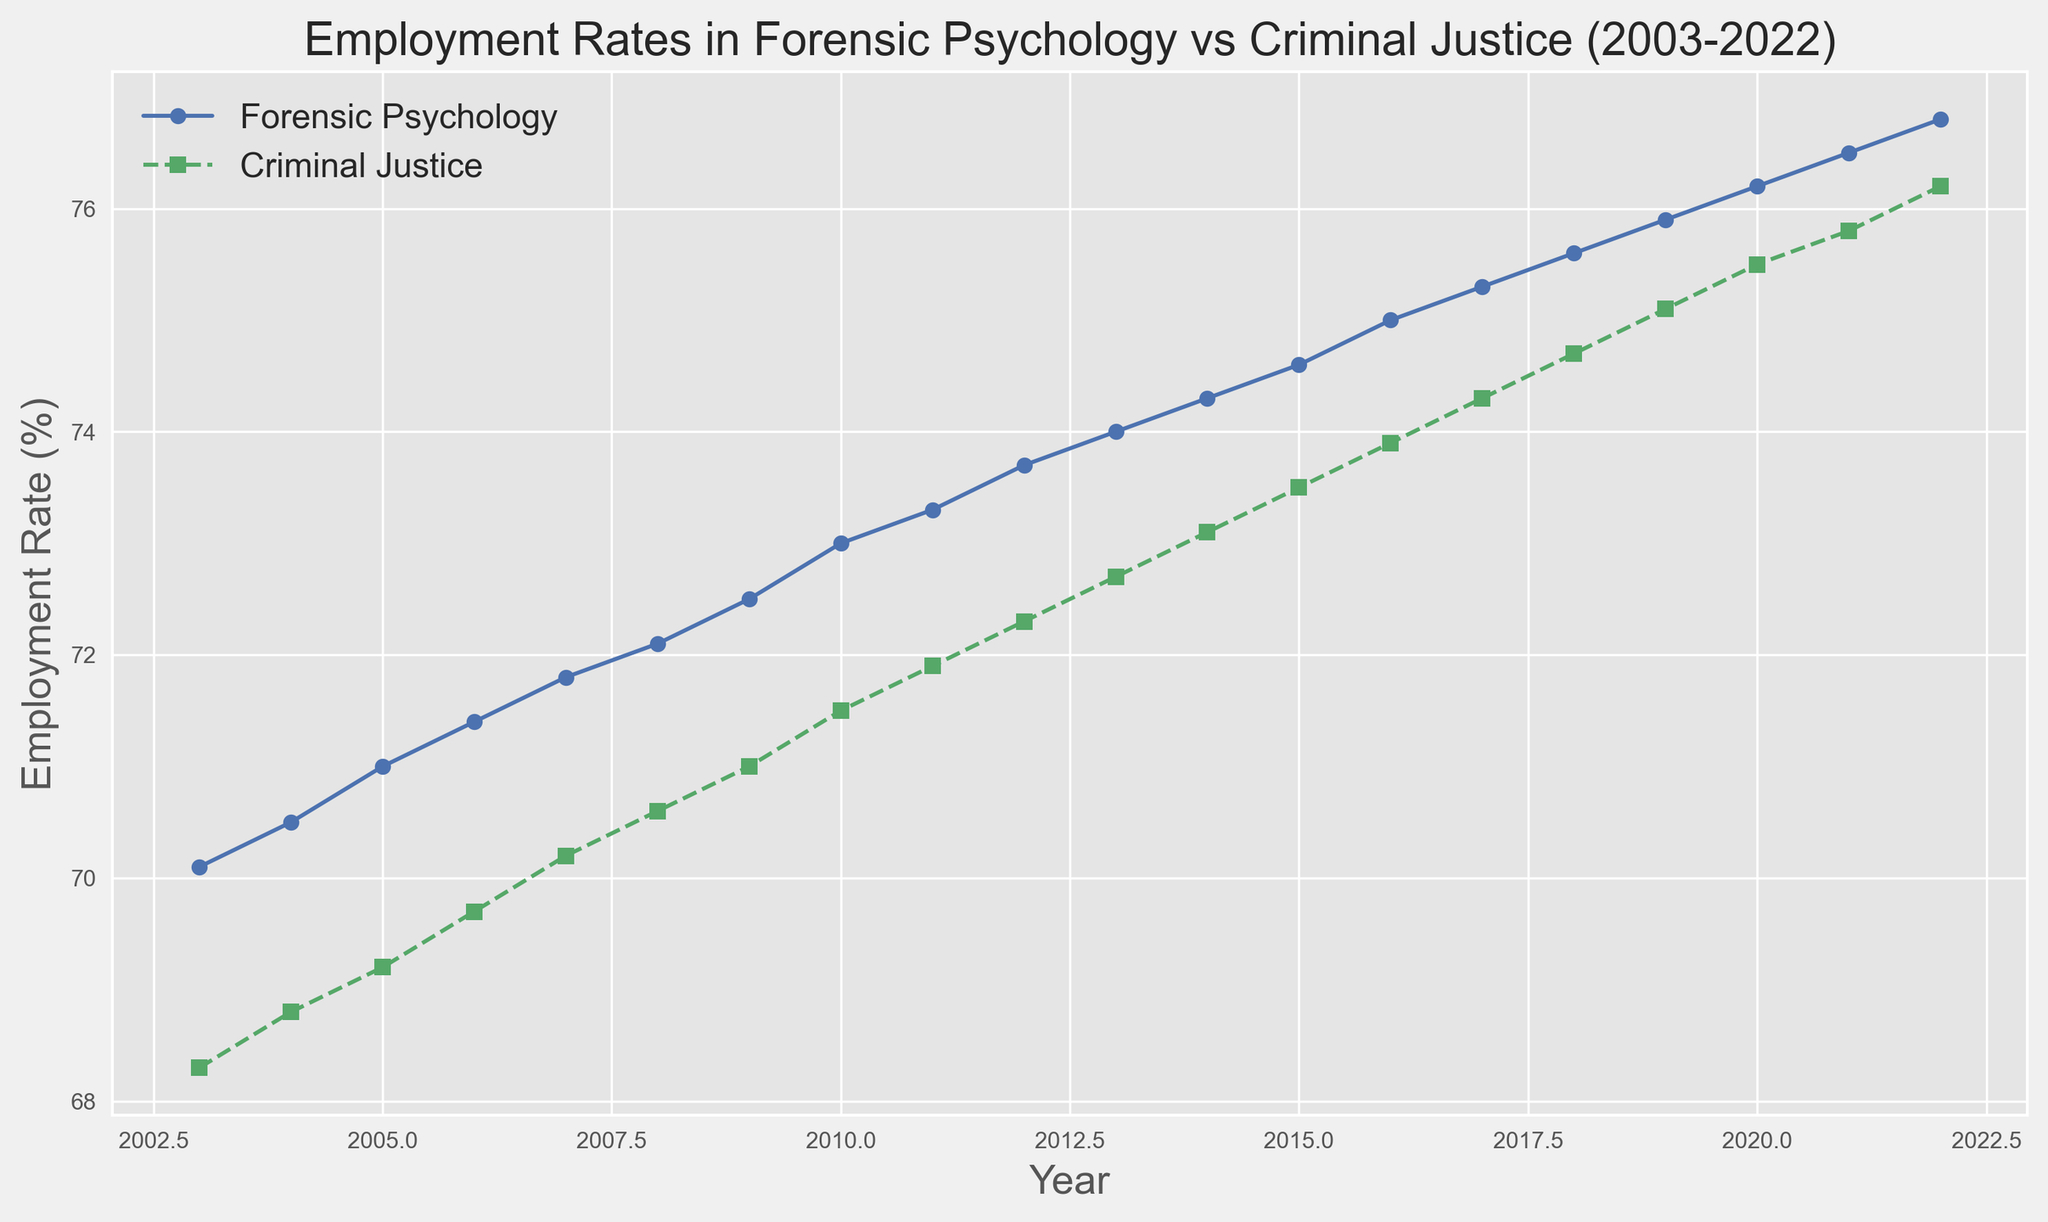What is the difference in employment rates between Forensic Psychology and Criminal Justice in 2003? In 2003, the employment rate for Forensic Psychology is 70.1%, and for Criminal Justice, it is 68.3%. Subtract the lower rate from the higher rate: 70.1% - 68.3% = 1.8%.
Answer: 1.8% Which field showed a greater increase in employment rate from 2003 to 2022? Forensic Psychology employment rate in 2003 is 70.1% and in 2022 is 76.8%, an increase of 76.8% - 70.1% = 6.7%. Criminal Justice employment rate in 2003 is 68.3% and in 2022 is 76.2%, an increase of 76.2% - 68.3% = 7.9%. Thus, Criminal Justice shows a greater increase.
Answer: Criminal Justice In which year did the Criminal Justice employment rate first exceed 70%? From the chart, locate the trend line for Criminal Justice and identify the year where the rate first moves above 70%. This happens in 2008 (70.6%).
Answer: 2008 Which field had a higher employment rate in 2015, and by how much? In 2015, the employment rate for Forensic Psychology is 74.6% and for Criminal Justice is 73.5%. The difference is 74.6% - 73.5% = 1.1%.
Answer: Forensic Psychology, 1.1% By comparing the visual attributes, how do the trends in the employment rates of the two fields differ? The Forensic Psychology employment rate grows steadily and consistently each year, identified by a smooth, upward-sloping line. In contrast, Criminal Justice starts with a similar trend but shows slightly more variability in the slopes of the line segments, suggesting less consistent growth.
Answer: Forensic Psychology shows steadier growth Over the whole period from 2003 to 2022, which field maintained higher employment rates on average? To find the average, sum the employment rates of each field for all years and divide by the number of years (20). Forensic Psychology: (70.1 + 70.5 + 71.0 + ... + 76.8) / 20 = 73.88%. Criminal Justice: (68.3 + 68.8 + 69.2 + ... + 76.2) / 20 = 72.39%. Forensic Psychology maintains a higher average employment rate.
Answer: Forensic Psychology In what year did both fields have the closest employment rates, and what was the difference? By analyzing the chart, the closest rates are seen where the lines come nearest. In 2021, Forensic Psychology: 76.5%, Criminal Justice: 75.8%. The difference is 76.5% - 75.8% = 0.7%.
Answer: 2021, 0.7% 